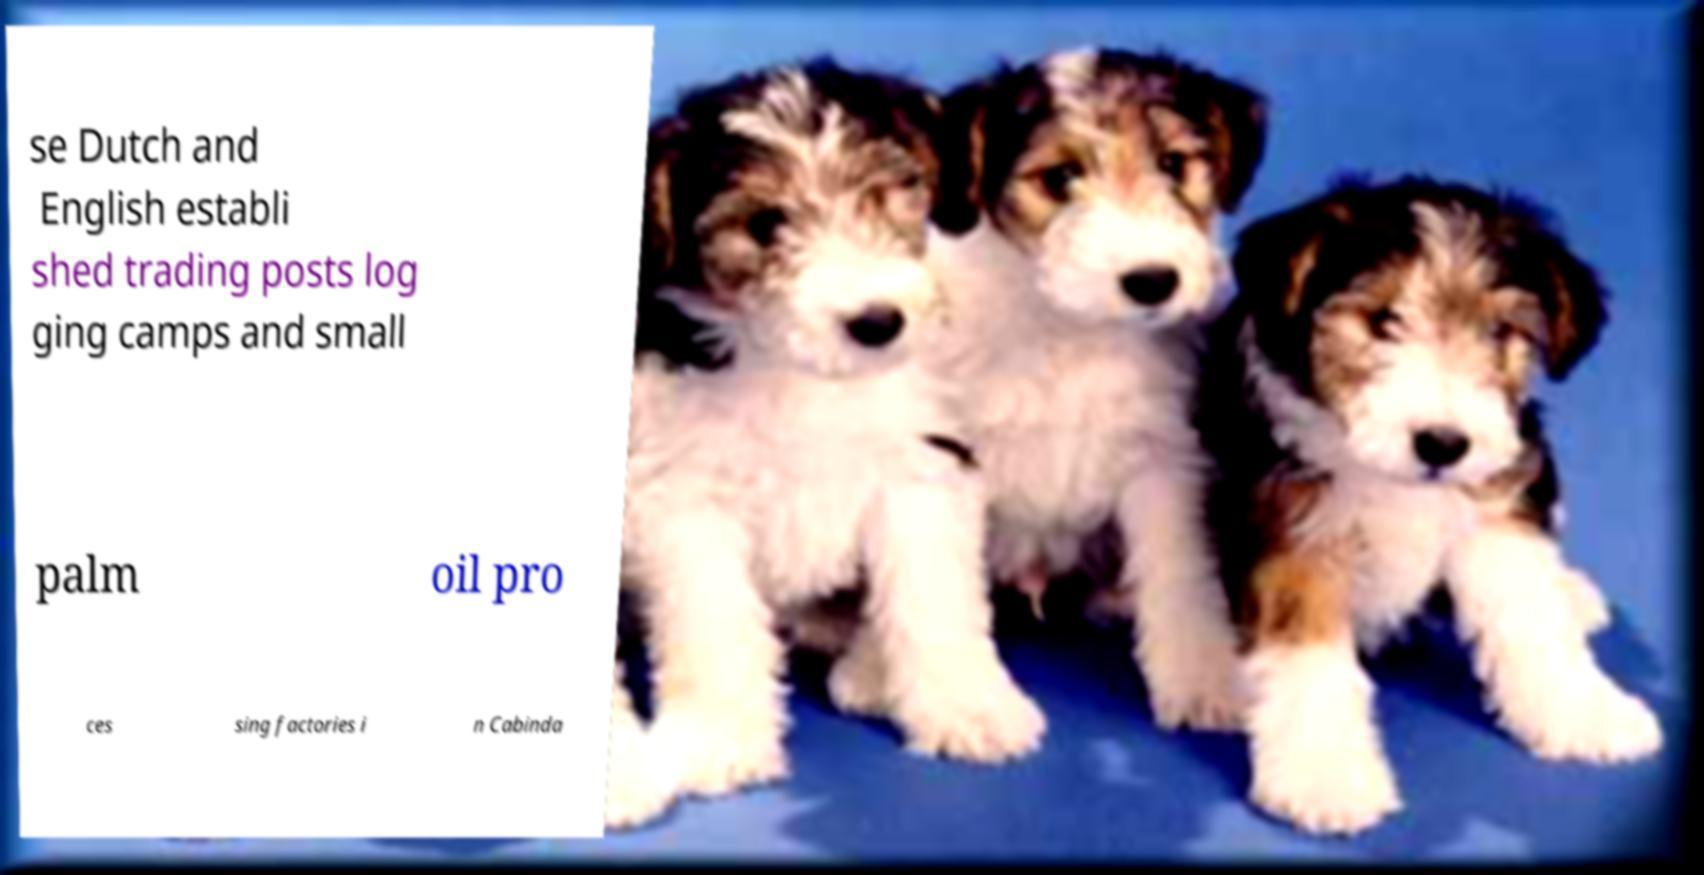Can you read and provide the text displayed in the image?This photo seems to have some interesting text. Can you extract and type it out for me? se Dutch and English establi shed trading posts log ging camps and small palm oil pro ces sing factories i n Cabinda 